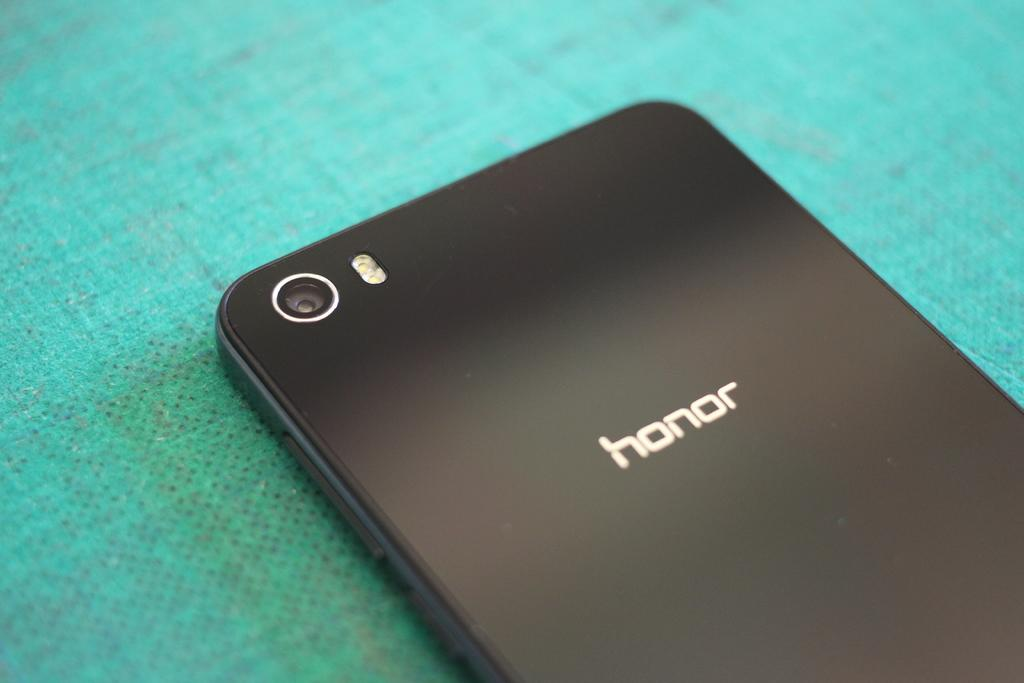<image>
Render a clear and concise summary of the photo. A black phone with honor engraved on its back. 